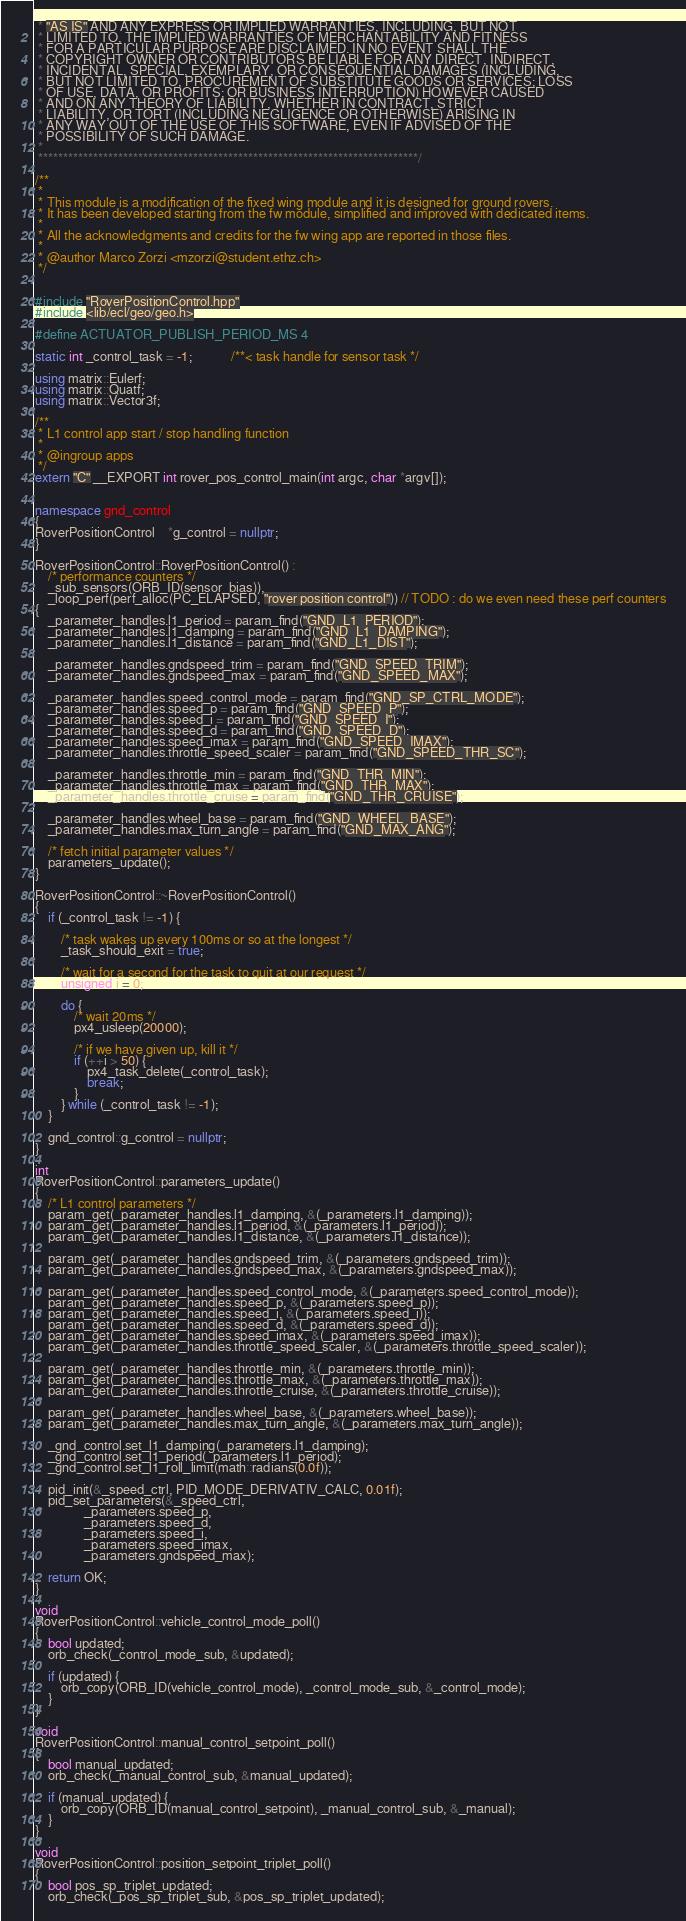<code> <loc_0><loc_0><loc_500><loc_500><_C++_> * "AS IS" AND ANY EXPRESS OR IMPLIED WARRANTIES, INCLUDING, BUT NOT
 * LIMITED TO, THE IMPLIED WARRANTIES OF MERCHANTABILITY AND FITNESS
 * FOR A PARTICULAR PURPOSE ARE DISCLAIMED. IN NO EVENT SHALL THE
 * COPYRIGHT OWNER OR CONTRIBUTORS BE LIABLE FOR ANY DIRECT, INDIRECT,
 * INCIDENTAL, SPECIAL, EXEMPLARY, OR CONSEQUENTIAL DAMAGES (INCLUDING,
 * BUT NOT LIMITED TO, PROCUREMENT OF SUBSTITUTE GOODS OR SERVICES; LOSS
 * OF USE, DATA, OR PROFITS; OR BUSINESS INTERRUPTION) HOWEVER CAUSED
 * AND ON ANY THEORY OF LIABILITY, WHETHER IN CONTRACT, STRICT
 * LIABILITY, OR TORT (INCLUDING NEGLIGENCE OR OTHERWISE) ARISING IN
 * ANY WAY OUT OF THE USE OF THIS SOFTWARE, EVEN IF ADVISED OF THE
 * POSSIBILITY OF SUCH DAMAGE.
 *
 ****************************************************************************/

/**
 *
 * This module is a modification of the fixed wing module and it is designed for ground rovers.
 * It has been developed starting from the fw module, simplified and improved with dedicated items.
 *
 * All the acknowledgments and credits for the fw wing app are reported in those files.
 *
 * @author Marco Zorzi <mzorzi@student.ethz.ch>
 */


#include "RoverPositionControl.hpp"
#include <lib/ecl/geo/geo.h>

#define ACTUATOR_PUBLISH_PERIOD_MS 4

static int _control_task = -1;			/**< task handle for sensor task */

using matrix::Eulerf;
using matrix::Quatf;
using matrix::Vector3f;

/**
 * L1 control app start / stop handling function
 *
 * @ingroup apps
 */
extern "C" __EXPORT int rover_pos_control_main(int argc, char *argv[]);


namespace gnd_control
{
RoverPositionControl	*g_control = nullptr;
}

RoverPositionControl::RoverPositionControl() :
	/* performance counters */
	_sub_sensors(ORB_ID(sensor_bias)),
	_loop_perf(perf_alloc(PC_ELAPSED, "rover position control")) // TODO : do we even need these perf counters
{
	_parameter_handles.l1_period = param_find("GND_L1_PERIOD");
	_parameter_handles.l1_damping = param_find("GND_L1_DAMPING");
	_parameter_handles.l1_distance = param_find("GND_L1_DIST");

	_parameter_handles.gndspeed_trim = param_find("GND_SPEED_TRIM");
	_parameter_handles.gndspeed_max = param_find("GND_SPEED_MAX");

	_parameter_handles.speed_control_mode = param_find("GND_SP_CTRL_MODE");
	_parameter_handles.speed_p = param_find("GND_SPEED_P");
	_parameter_handles.speed_i = param_find("GND_SPEED_I");
	_parameter_handles.speed_d = param_find("GND_SPEED_D");
	_parameter_handles.speed_imax = param_find("GND_SPEED_IMAX");
	_parameter_handles.throttle_speed_scaler = param_find("GND_SPEED_THR_SC");

	_parameter_handles.throttle_min = param_find("GND_THR_MIN");
	_parameter_handles.throttle_max = param_find("GND_THR_MAX");
	_parameter_handles.throttle_cruise = param_find("GND_THR_CRUISE");

	_parameter_handles.wheel_base = param_find("GND_WHEEL_BASE");
	_parameter_handles.max_turn_angle = param_find("GND_MAX_ANG");

	/* fetch initial parameter values */
	parameters_update();
}

RoverPositionControl::~RoverPositionControl()
{
	if (_control_task != -1) {

		/* task wakes up every 100ms or so at the longest */
		_task_should_exit = true;

		/* wait for a second for the task to quit at our request */
		unsigned i = 0;

		do {
			/* wait 20ms */
			px4_usleep(20000);

			/* if we have given up, kill it */
			if (++i > 50) {
				px4_task_delete(_control_task);
				break;
			}
		} while (_control_task != -1);
	}

	gnd_control::g_control = nullptr;
}

int
RoverPositionControl::parameters_update()
{
	/* L1 control parameters */
	param_get(_parameter_handles.l1_damping, &(_parameters.l1_damping));
	param_get(_parameter_handles.l1_period, &(_parameters.l1_period));
	param_get(_parameter_handles.l1_distance, &(_parameters.l1_distance));

	param_get(_parameter_handles.gndspeed_trim, &(_parameters.gndspeed_trim));
	param_get(_parameter_handles.gndspeed_max, &(_parameters.gndspeed_max));

	param_get(_parameter_handles.speed_control_mode, &(_parameters.speed_control_mode));
	param_get(_parameter_handles.speed_p, &(_parameters.speed_p));
	param_get(_parameter_handles.speed_i, &(_parameters.speed_i));
	param_get(_parameter_handles.speed_d, &(_parameters.speed_d));
	param_get(_parameter_handles.speed_imax, &(_parameters.speed_imax));
	param_get(_parameter_handles.throttle_speed_scaler, &(_parameters.throttle_speed_scaler));

	param_get(_parameter_handles.throttle_min, &(_parameters.throttle_min));
	param_get(_parameter_handles.throttle_max, &(_parameters.throttle_max));
	param_get(_parameter_handles.throttle_cruise, &(_parameters.throttle_cruise));

	param_get(_parameter_handles.wheel_base, &(_parameters.wheel_base));
	param_get(_parameter_handles.max_turn_angle, &(_parameters.max_turn_angle));

	_gnd_control.set_l1_damping(_parameters.l1_damping);
	_gnd_control.set_l1_period(_parameters.l1_period);
	_gnd_control.set_l1_roll_limit(math::radians(0.0f));

	pid_init(&_speed_ctrl, PID_MODE_DERIVATIV_CALC, 0.01f);
	pid_set_parameters(&_speed_ctrl,
			   _parameters.speed_p,
			   _parameters.speed_d,
			   _parameters.speed_i,
			   _parameters.speed_imax,
			   _parameters.gndspeed_max);

	return OK;
}

void
RoverPositionControl::vehicle_control_mode_poll()
{
	bool updated;
	orb_check(_control_mode_sub, &updated);

	if (updated) {
		orb_copy(ORB_ID(vehicle_control_mode), _control_mode_sub, &_control_mode);
	}
}

void
RoverPositionControl::manual_control_setpoint_poll()
{
	bool manual_updated;
	orb_check(_manual_control_sub, &manual_updated);

	if (manual_updated) {
		orb_copy(ORB_ID(manual_control_setpoint), _manual_control_sub, &_manual);
	}
}

void
RoverPositionControl::position_setpoint_triplet_poll()
{
	bool pos_sp_triplet_updated;
	orb_check(_pos_sp_triplet_sub, &pos_sp_triplet_updated);
</code> 